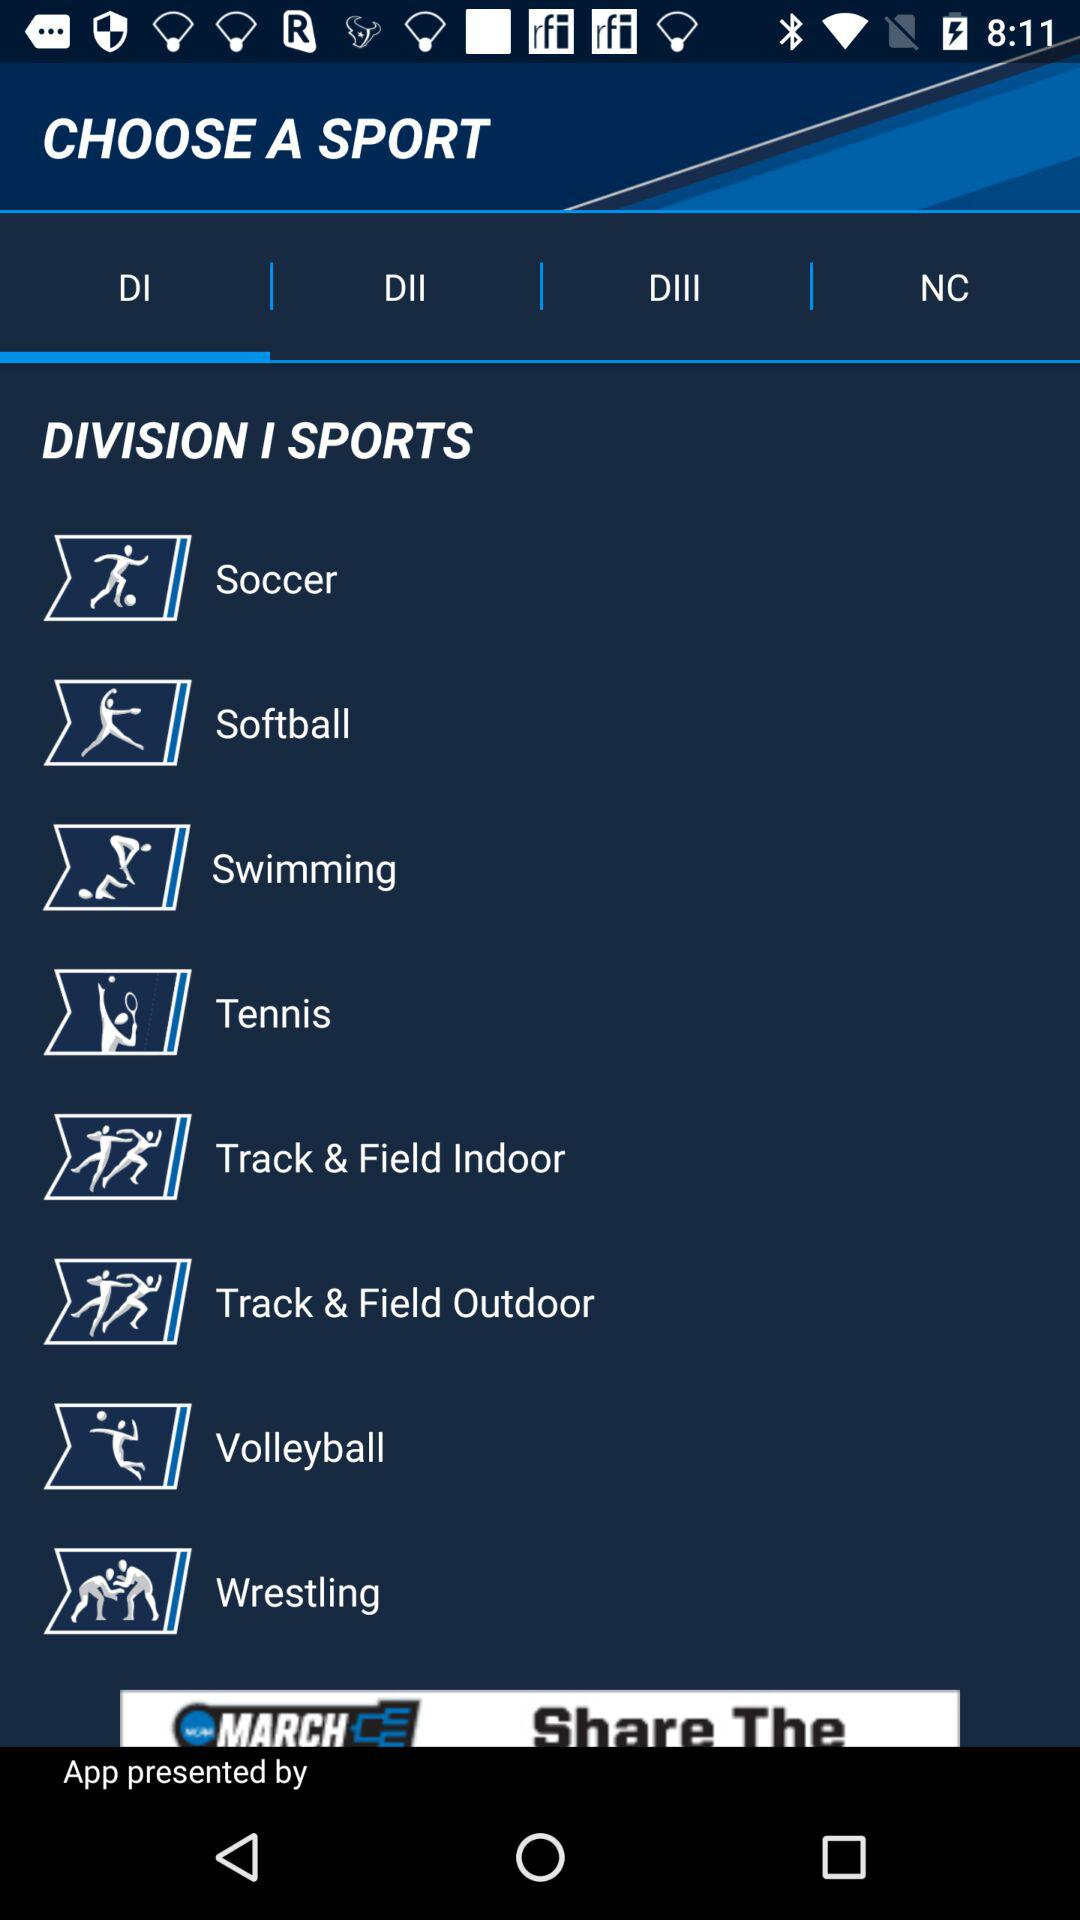Which option is selected? The selected option is "DI". 